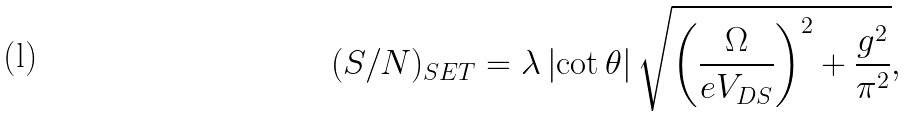Convert formula to latex. <formula><loc_0><loc_0><loc_500><loc_500>( S / N ) _ { S E T } = \lambda \left | \cot \theta \right | \sqrt { \left ( \frac { \Omega } { e V _ { D S } } \right ) ^ { 2 } + \frac { g ^ { 2 } } { \pi ^ { 2 } } } ,</formula> 